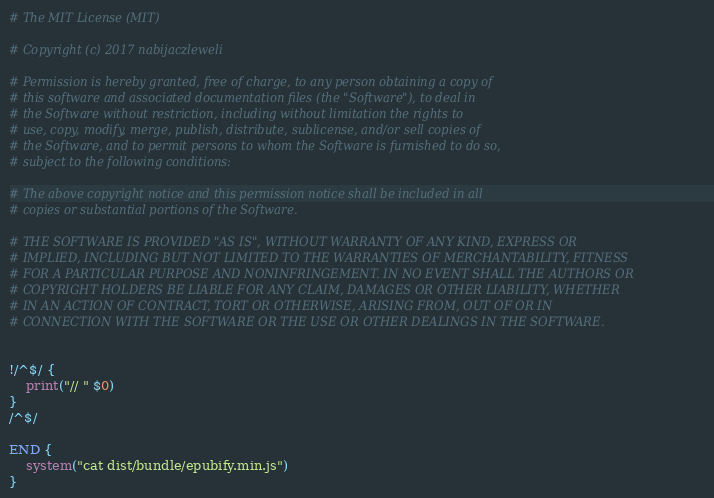Convert code to text. <code><loc_0><loc_0><loc_500><loc_500><_Awk_># The MIT License (MIT)

# Copyright (c) 2017 nabijaczleweli

# Permission is hereby granted, free of charge, to any person obtaining a copy of
# this software and associated documentation files (the "Software"), to deal in
# the Software without restriction, including without limitation the rights to
# use, copy, modify, merge, publish, distribute, sublicense, and/or sell copies of
# the Software, and to permit persons to whom the Software is furnished to do so,
# subject to the following conditions:

# The above copyright notice and this permission notice shall be included in all
# copies or substantial portions of the Software.

# THE SOFTWARE IS PROVIDED "AS IS", WITHOUT WARRANTY OF ANY KIND, EXPRESS OR
# IMPLIED, INCLUDING BUT NOT LIMITED TO THE WARRANTIES OF MERCHANTABILITY, FITNESS
# FOR A PARTICULAR PURPOSE AND NONINFRINGEMENT. IN NO EVENT SHALL THE AUTHORS OR
# COPYRIGHT HOLDERS BE LIABLE FOR ANY CLAIM, DAMAGES OR OTHER LIABILITY, WHETHER
# IN AN ACTION OF CONTRACT, TORT OR OTHERWISE, ARISING FROM, OUT OF OR IN
# CONNECTION WITH THE SOFTWARE OR THE USE OR OTHER DEALINGS IN THE SOFTWARE.


!/^$/ {
	print("// " $0)
}
/^$/

END {
	system("cat dist/bundle/epubify.min.js")
}
</code> 